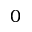Convert formula to latex. <formula><loc_0><loc_0><loc_500><loc_500>0</formula> 